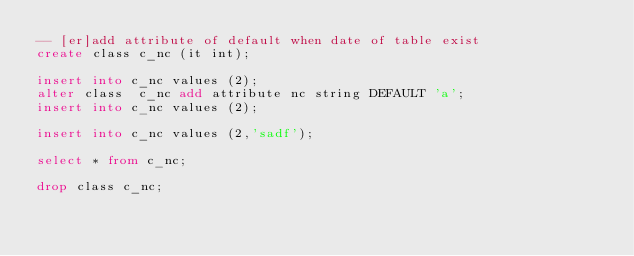<code> <loc_0><loc_0><loc_500><loc_500><_SQL_>-- [er]add attribute of default when date of table exist
create class c_nc (it int);

insert into c_nc values (2);
alter class  c_nc add attribute nc string DEFAULT 'a';
insert into c_nc values (2);

insert into c_nc values (2,'sadf');

select * from c_nc;

drop class c_nc;</code> 